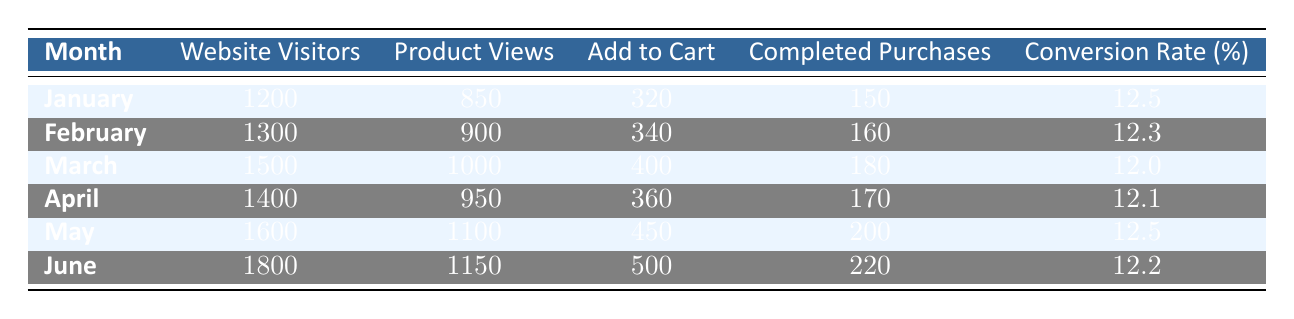What is the conversion rate for March? The conversion rate for March is explicitly listed in the table under the "Conversion Rate (%)" column for that month. The value is 12.0.
Answer: 12.0 What was the total number of completed purchases from January to June? To find the total completed purchases, sum the "Completed Purchases" column for all months: 150 + 160 + 180 + 170 + 200 + 220 = 1080.
Answer: 1080 Did the number of website visitors increase from January to February? By comparing the "Website Visitors" for January (1200) and February (1300), we can see that the number increased from January to February.
Answer: Yes Which month had the highest number of product views? The "Product Views" column shows that the highest value is in May with 1100 product views.
Answer: May What is the average conversion rate from January to June? First, sum the conversion rates: 12.5 + 12.3 + 12.0 + 12.1 + 12.5 + 12.2 = 73.6. Then divide by the number of months (6): 73.6 / 6 = 12.27.
Answer: 12.27 Was the conversion rate in April higher than in February? Looking at the conversion rates in the table, April has a rate of 12.1 while February has a rate of 12.3. Since 12.1 is less than 12.3, we can conclude that April's rate was lower.
Answer: No How many more add-to-cart actions occurred in June compared to January? By subtracting January's add-to-cart actions (320) from June's (500): 500 - 320 = 180.
Answer: 180 What was the average number of add-to-cart actions per month? To find the average, first sum the add-to-cart actions: 320 + 340 + 400 + 360 + 450 + 500 = 2670. Then divide by the number of months (6): 2670 / 6 = 445.
Answer: 445 